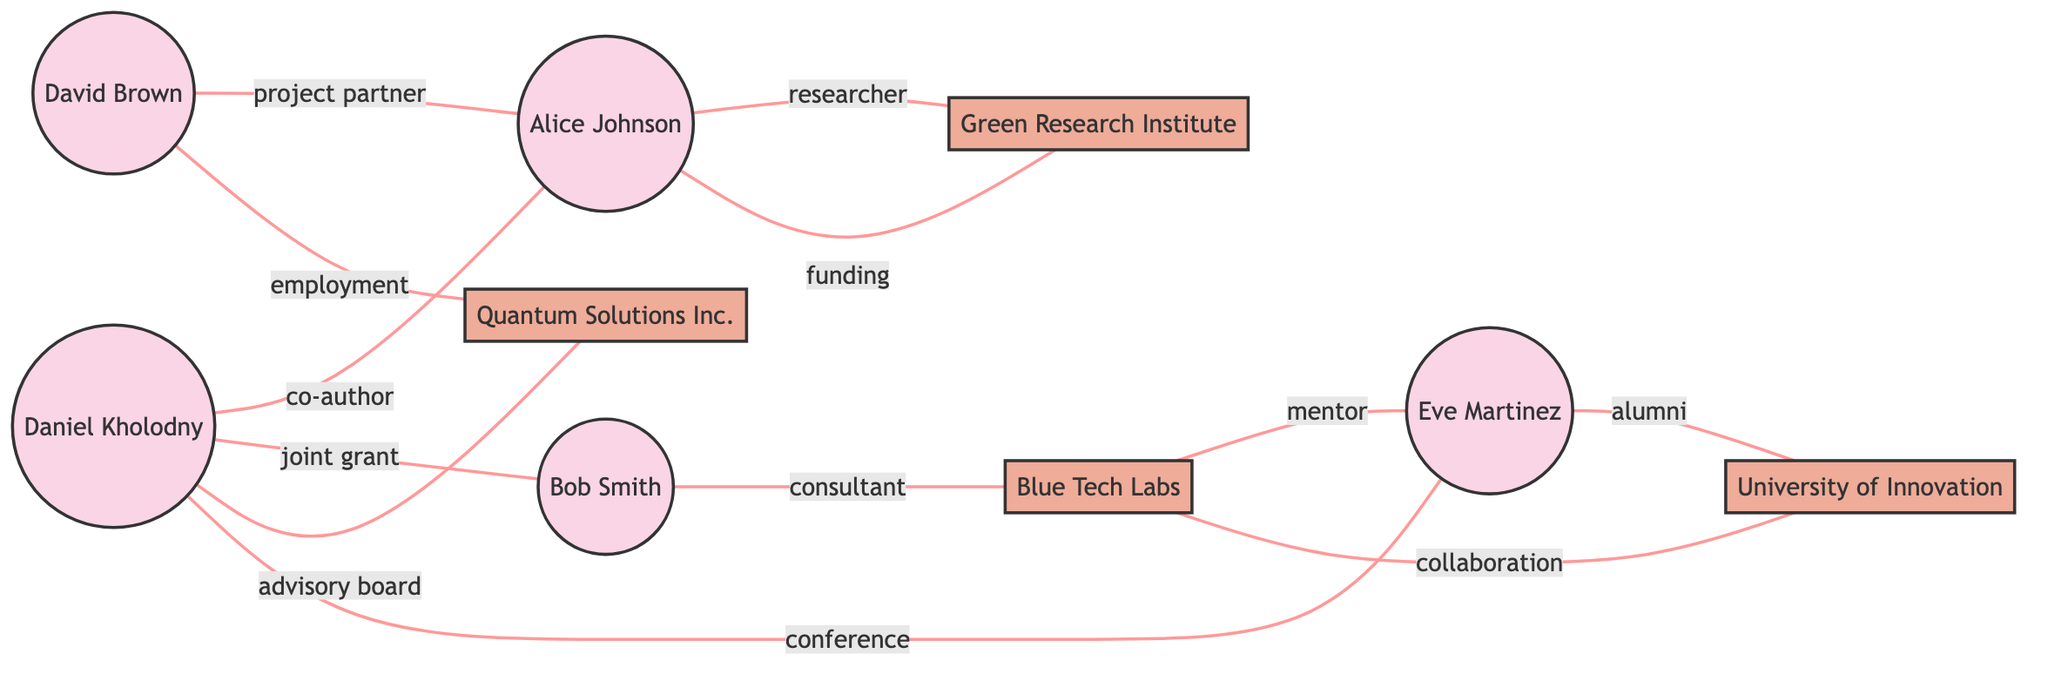What is the total number of nodes in the diagram? There are 9 nodes listed, which include 5 individuals and 4 institutions.
Answer: 9 Which two nodes are connected by the edge labeled "co-author"? The edge labeled "co-author" connects Daniel Kholodny (node 1) and Alice Johnson (node 2).
Answer: Daniel Kholodny, Alice Johnson Who are the project partners with David Brown? The edge labeled "project partner" connects David Brown (node 5) and Alice Johnson (node 2).
Answer: Alice Johnson What type of collaboration exists between the University of Innovation and Blue Tech Labs? The edge labeled "collaboration" indicates a relationship between the University of Innovation (node 8) and Blue Tech Labs (node 7).
Answer: collaboration Which institutions is Alice Johnson associated with? Alice Johnson is connected to the Green Research Institute (node 6) as a researcher and David Brown (node 5) as a project partner.
Answer: Green Research Institute, David Brown What is the relationship between Daniel Kholodny and Quantum Solutions Inc.? The relationship is described by the edge labeled "advisory board," which connects Daniel Kholodny (node 1) to Quantum Solutions Inc. (node 9).
Answer: advisory board How many different types of edges are present in the diagram? There are 7 unique edge labels: co-author, joint grant, researcher, consultant, conference, project partner, employment, advisory board, collaboration, and funding.
Answer: 10 Which node has the most connections? By examining the edges, Daniel Kholodny (node 1) has connections to four different nodes: Alice Johnson, Bob Smith, Eve Martinez, and Quantum Solutions Inc.
Answer: Daniel Kholodny 